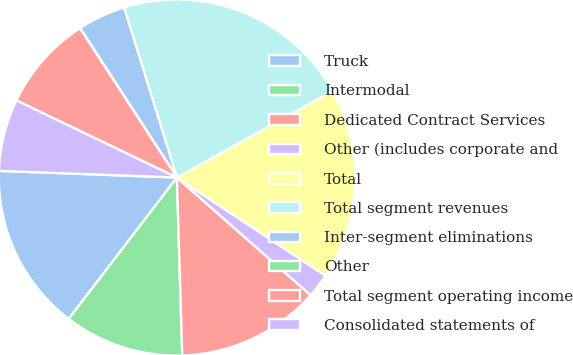Convert chart. <chart><loc_0><loc_0><loc_500><loc_500><pie_chart><fcel>Truck<fcel>Intermodal<fcel>Dedicated Contract Services<fcel>Other (includes corporate and<fcel>Total<fcel>Total segment revenues<fcel>Inter-segment eliminations<fcel>Other<fcel>Total segment operating income<fcel>Consolidated statements of<nl><fcel>15.2%<fcel>10.87%<fcel>13.04%<fcel>2.19%<fcel>17.37%<fcel>21.71%<fcel>4.36%<fcel>0.02%<fcel>8.7%<fcel>6.53%<nl></chart> 